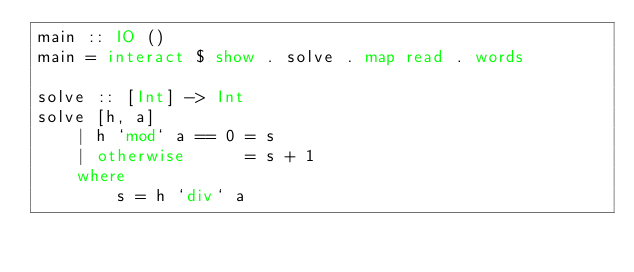<code> <loc_0><loc_0><loc_500><loc_500><_Haskell_>main :: IO ()
main = interact $ show . solve . map read . words

solve :: [Int] -> Int
solve [h, a]
    | h `mod` a == 0 = s
    | otherwise      = s + 1
    where
        s = h `div` a</code> 